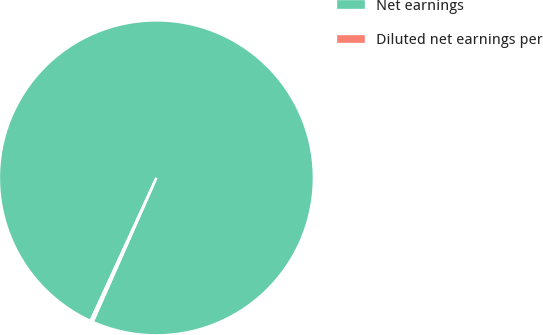Convert chart. <chart><loc_0><loc_0><loc_500><loc_500><pie_chart><fcel>Net earnings<fcel>Diluted net earnings per<nl><fcel>99.76%<fcel>0.24%<nl></chart> 